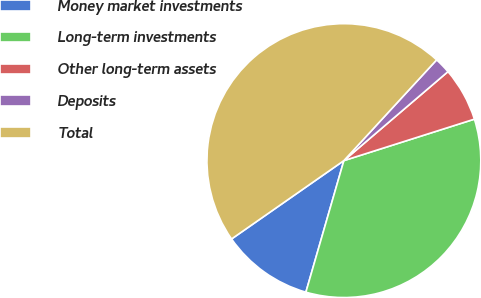Convert chart to OTSL. <chart><loc_0><loc_0><loc_500><loc_500><pie_chart><fcel>Money market investments<fcel>Long-term investments<fcel>Other long-term assets<fcel>Deposits<fcel>Total<nl><fcel>10.83%<fcel>34.37%<fcel>6.36%<fcel>1.9%<fcel>46.54%<nl></chart> 